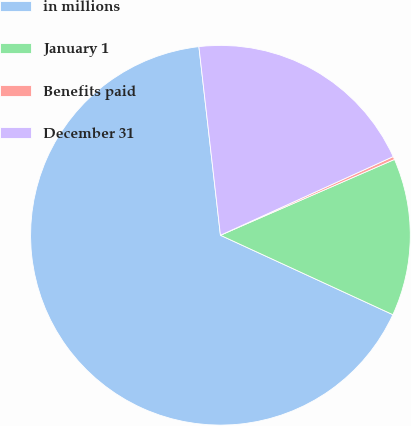<chart> <loc_0><loc_0><loc_500><loc_500><pie_chart><fcel>in millions<fcel>January 1<fcel>Benefits paid<fcel>December 31<nl><fcel>66.32%<fcel>13.41%<fcel>0.26%<fcel>20.01%<nl></chart> 